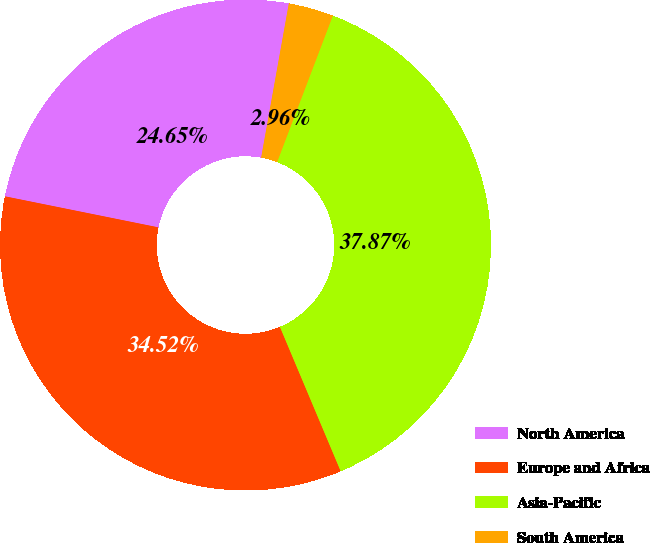<chart> <loc_0><loc_0><loc_500><loc_500><pie_chart><fcel>North America<fcel>Europe and Africa<fcel>Asia-Pacific<fcel>South America<nl><fcel>24.65%<fcel>34.52%<fcel>37.87%<fcel>2.96%<nl></chart> 